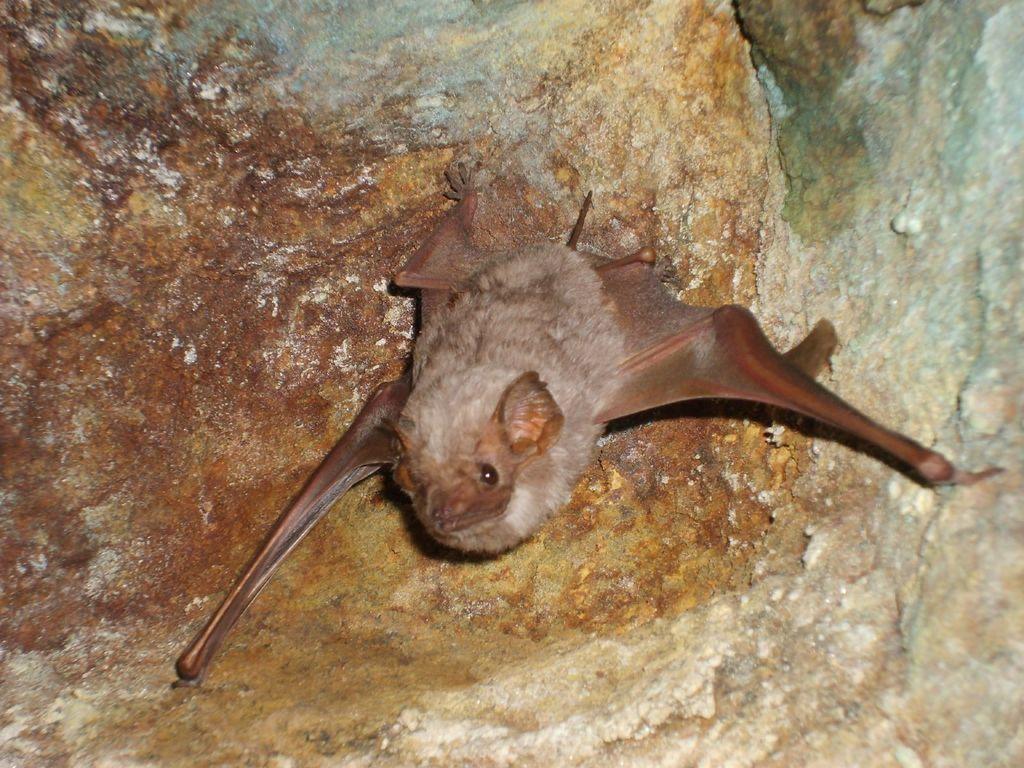Can you describe this image briefly? In this image we can see bat on the wall. 